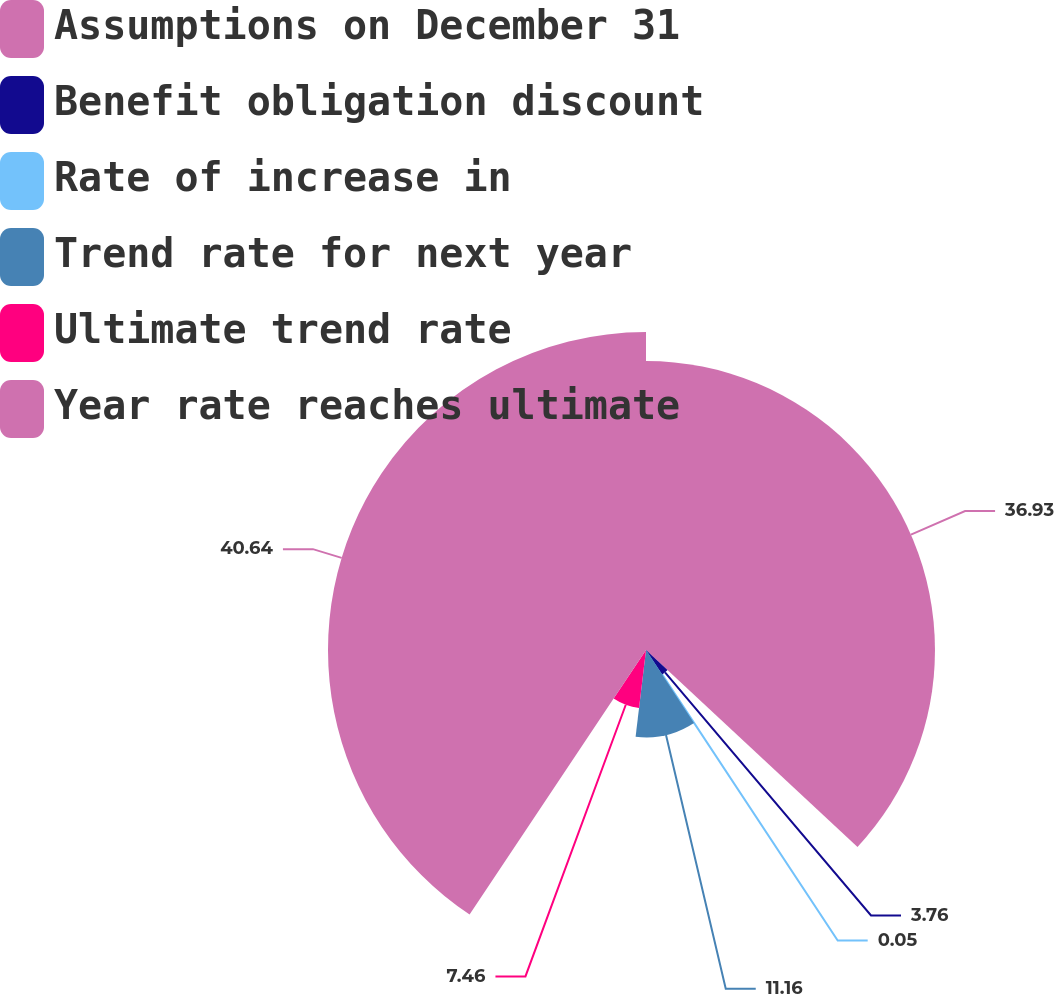Convert chart. <chart><loc_0><loc_0><loc_500><loc_500><pie_chart><fcel>Assumptions on December 31<fcel>Benefit obligation discount<fcel>Rate of increase in<fcel>Trend rate for next year<fcel>Ultimate trend rate<fcel>Year rate reaches ultimate<nl><fcel>36.93%<fcel>3.76%<fcel>0.05%<fcel>11.16%<fcel>7.46%<fcel>40.64%<nl></chart> 